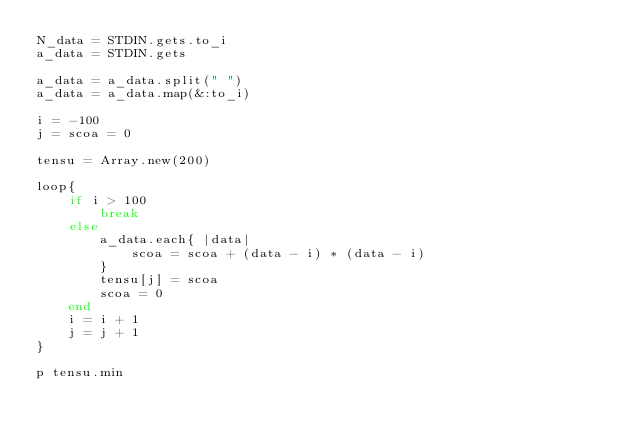Convert code to text. <code><loc_0><loc_0><loc_500><loc_500><_Ruby_>N_data = STDIN.gets.to_i
a_data = STDIN.gets

a_data = a_data.split(" ")
a_data = a_data.map(&:to_i)

i = -100
j = scoa = 0

tensu = Array.new(200)

loop{
    if i > 100
        break
    else
        a_data.each{ |data|
            scoa = scoa + (data - i) * (data - i)
        }
        tensu[j] = scoa
        scoa = 0
    end
    i = i + 1
    j = j + 1
}

p tensu.min</code> 